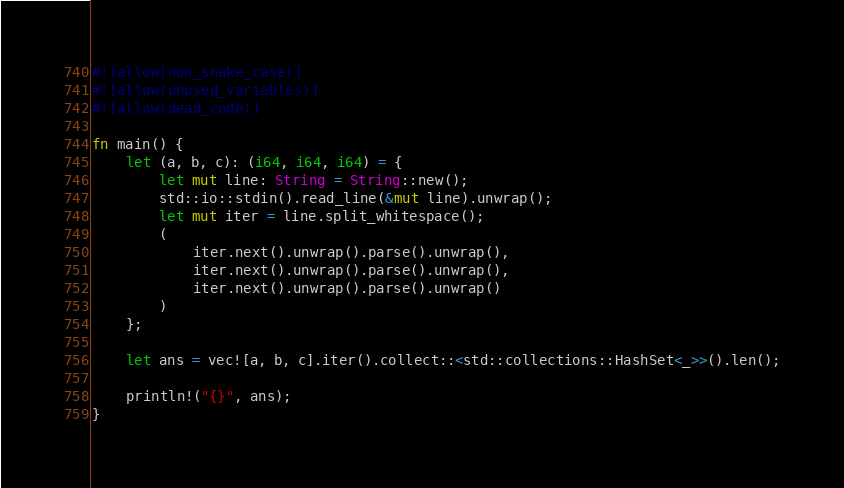<code> <loc_0><loc_0><loc_500><loc_500><_Rust_>#![allow(non_snake_case)]
#![allow(unused_variables)]
#![allow(dead_code)]

fn main() {
    let (a, b, c): (i64, i64, i64) = {
        let mut line: String = String::new();
        std::io::stdin().read_line(&mut line).unwrap();
        let mut iter = line.split_whitespace();
        (
            iter.next().unwrap().parse().unwrap(),
            iter.next().unwrap().parse().unwrap(),
            iter.next().unwrap().parse().unwrap()
        )
    };

    let ans = vec![a, b, c].iter().collect::<std::collections::HashSet<_>>().len();

    println!("{}", ans);
}</code> 